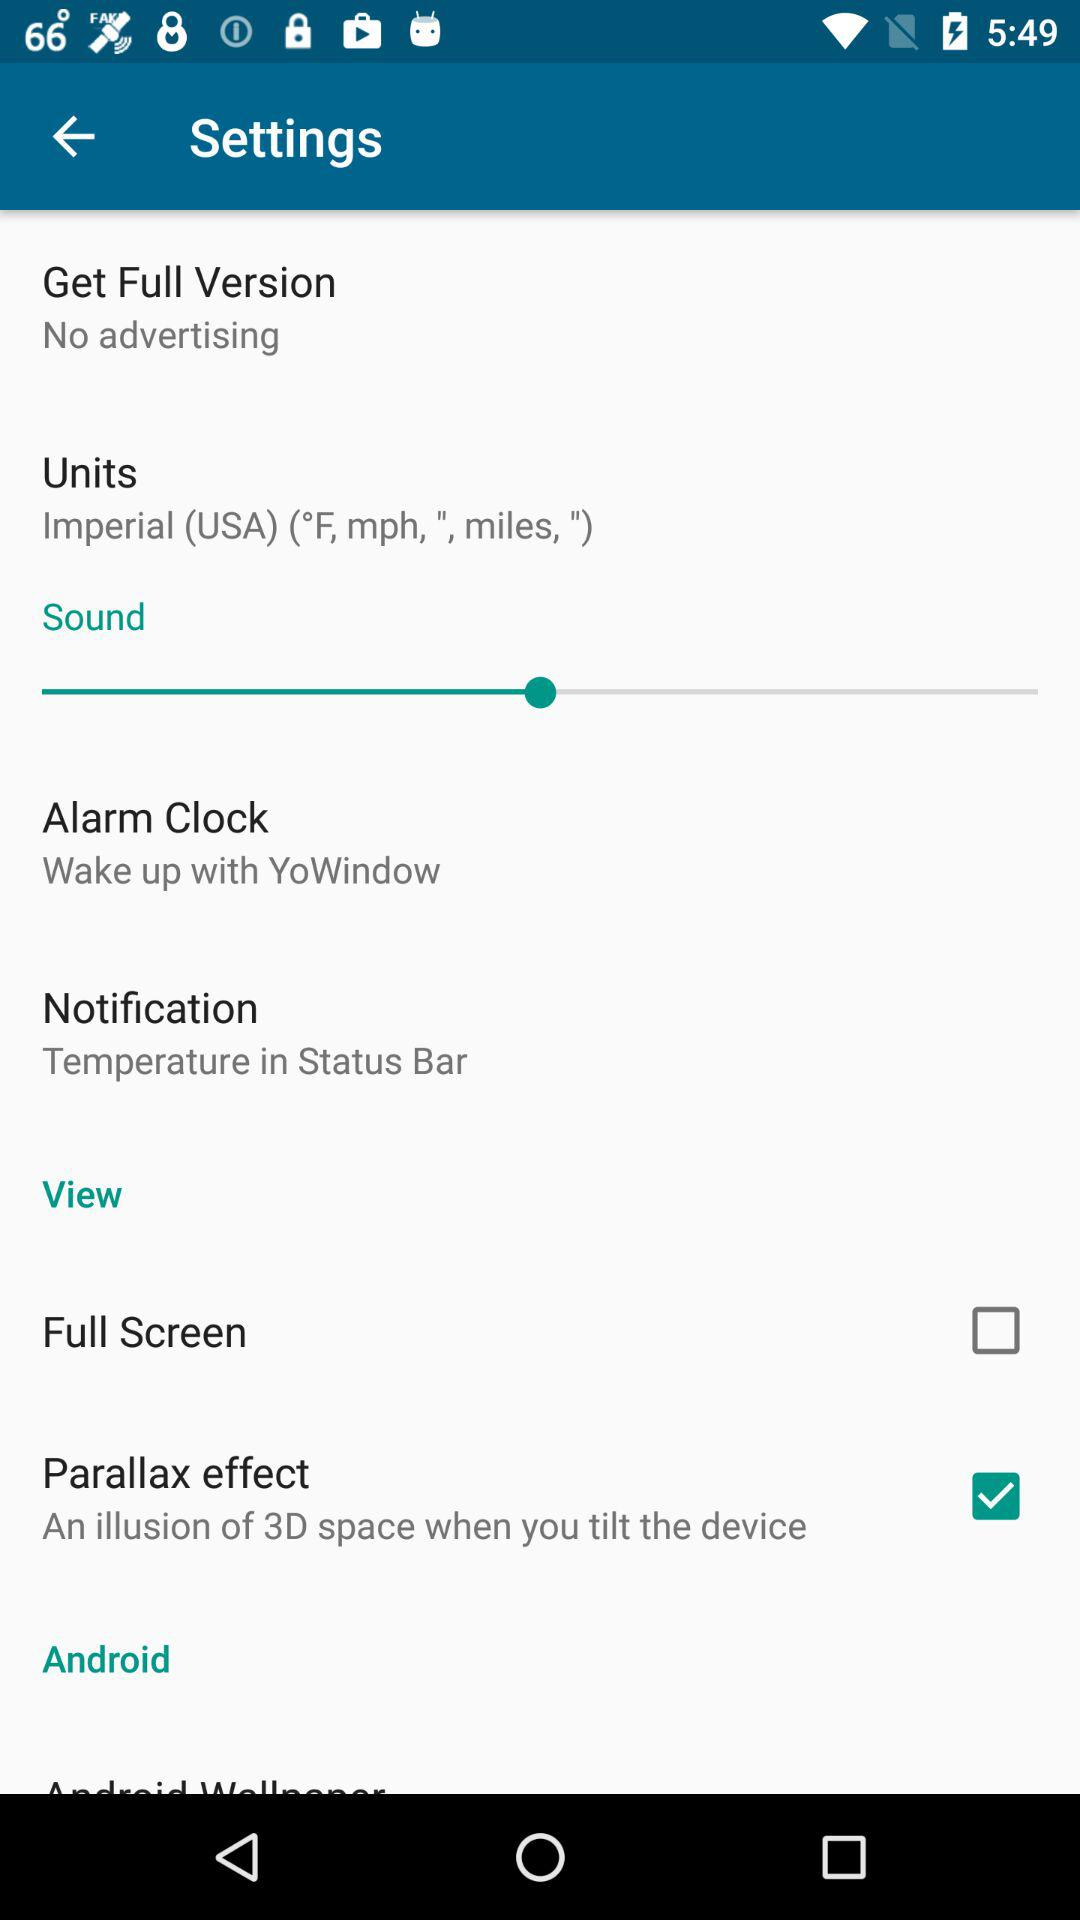How many of the settings have a checkbox?
Answer the question using a single word or phrase. 2 